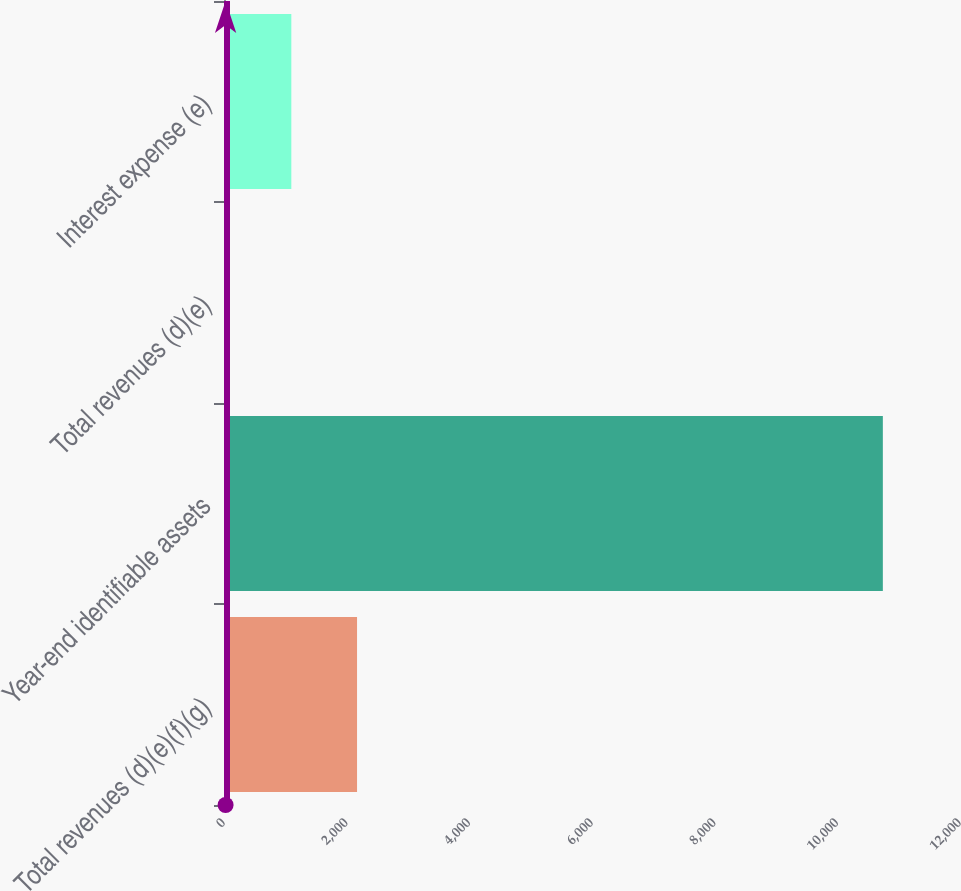Convert chart. <chart><loc_0><loc_0><loc_500><loc_500><bar_chart><fcel>Total revenues (d)(e)(f)(g)<fcel>Year-end identifiable assets<fcel>Total revenues (d)(e)<fcel>Interest expense (e)<nl><fcel>2169.2<fcel>10742<fcel>26<fcel>1097.6<nl></chart> 